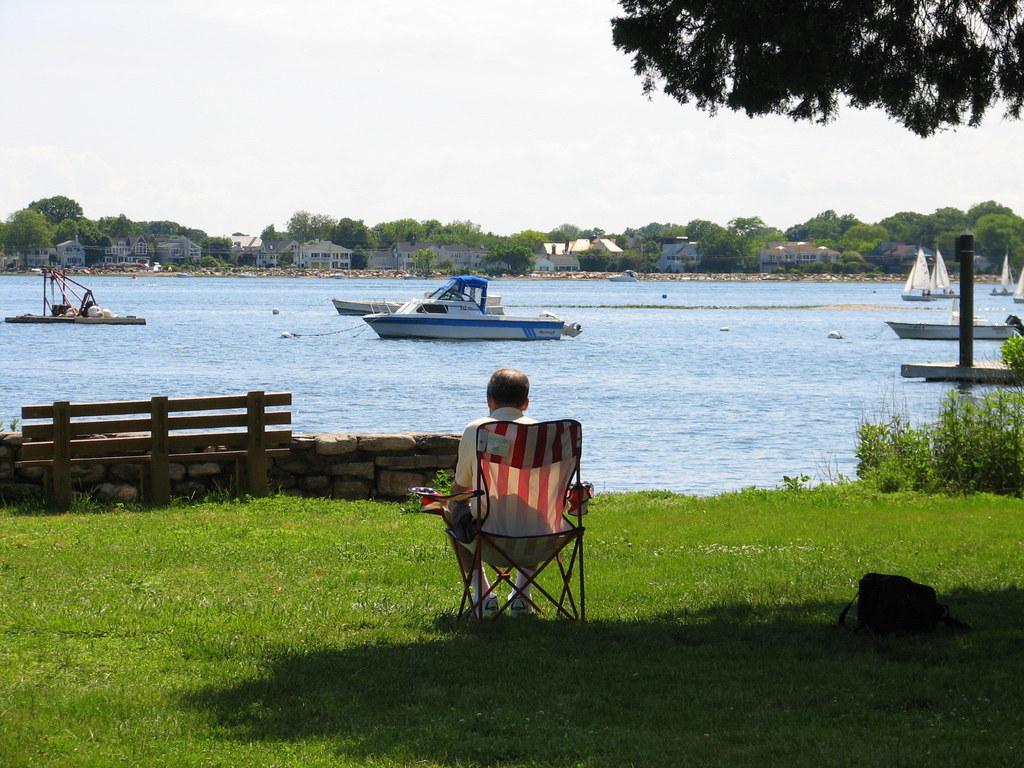How would you summarize this image in a sentence or two? In this image we can see a person sitting on the chair. There is an object on the ground at the right bottom of the image. There is a grassy land in the image. We can see the sea in the image. There are few houses in the image. There are many trees in the image. There are few watercraft in the image. We can see the sky in the image. 